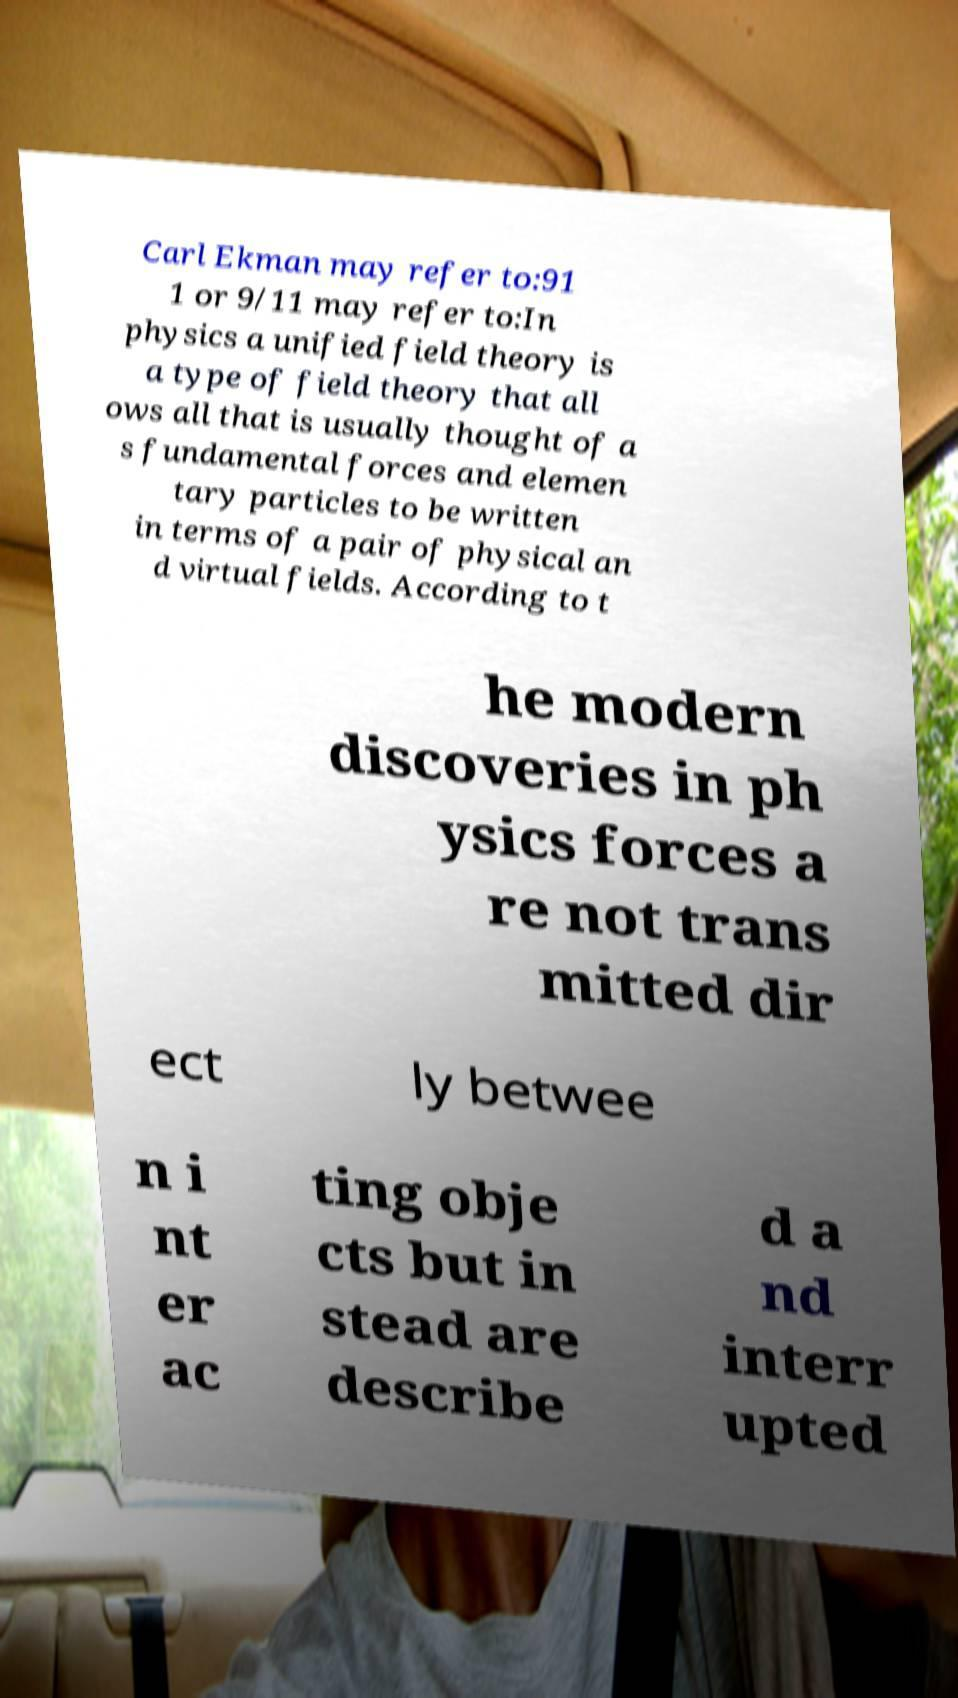Can you read and provide the text displayed in the image?This photo seems to have some interesting text. Can you extract and type it out for me? Carl Ekman may refer to:91 1 or 9/11 may refer to:In physics a unified field theory is a type of field theory that all ows all that is usually thought of a s fundamental forces and elemen tary particles to be written in terms of a pair of physical an d virtual fields. According to t he modern discoveries in ph ysics forces a re not trans mitted dir ect ly betwee n i nt er ac ting obje cts but in stead are describe d a nd interr upted 